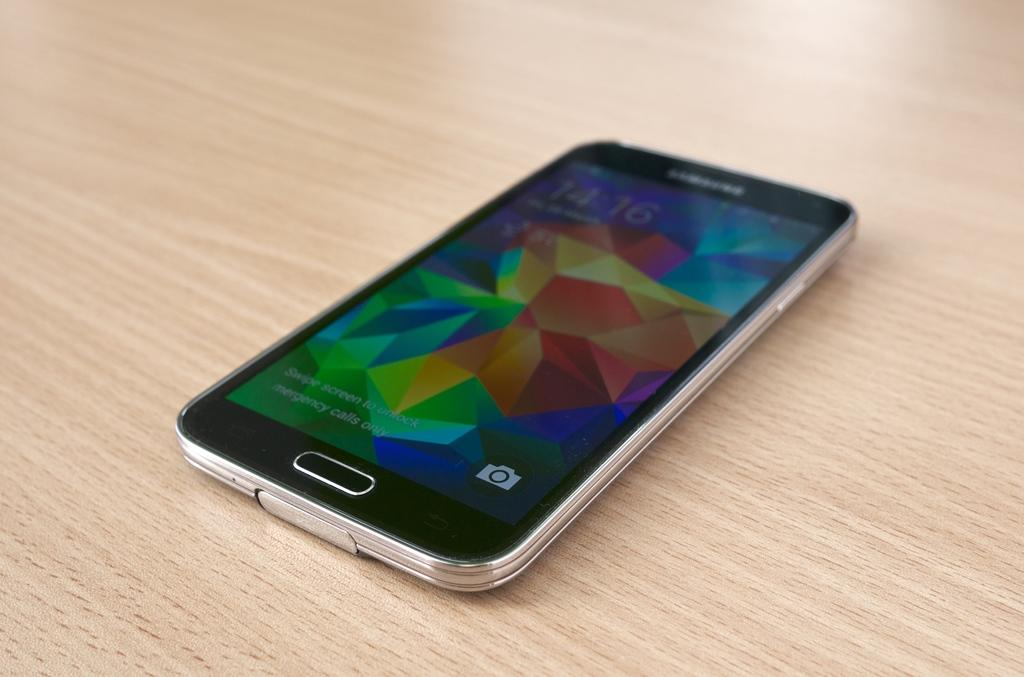<image>
Offer a succinct explanation of the picture presented. a smart phone displaying the time of 14:16 with multiple colors on the display 